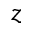Convert formula to latex. <formula><loc_0><loc_0><loc_500><loc_500>z</formula> 